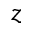Convert formula to latex. <formula><loc_0><loc_0><loc_500><loc_500>z</formula> 